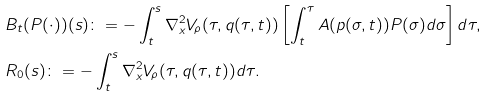Convert formula to latex. <formula><loc_0><loc_0><loc_500><loc_500>& B _ { t } ( P ( \cdot ) ) ( s ) \colon = - \int _ { t } ^ { s } \nabla _ { x } ^ { 2 } V _ { \rho } ( \tau , q ( \tau , t ) ) \left [ \int _ { t } ^ { \tau } A ( p ( \sigma , t ) ) P ( \sigma ) d \sigma \right ] d \tau , \\ & R _ { 0 } ( s ) \colon = - \int _ { t } ^ { s } \nabla _ { x } ^ { 2 } V _ { \rho } ( \tau , q ( \tau , t ) ) d \tau .</formula> 